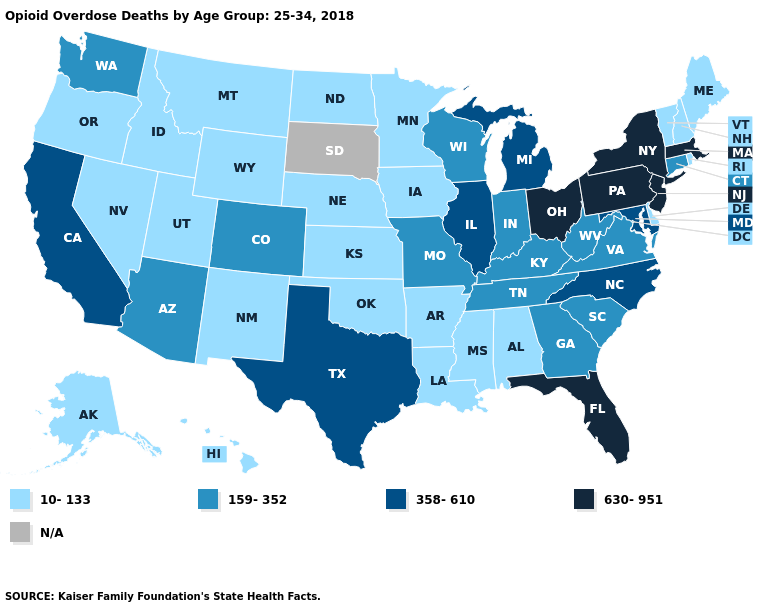Does Iowa have the lowest value in the USA?
Write a very short answer. Yes. Does the map have missing data?
Quick response, please. Yes. What is the highest value in the USA?
Give a very brief answer. 630-951. Among the states that border Illinois , does Missouri have the highest value?
Give a very brief answer. Yes. How many symbols are there in the legend?
Answer briefly. 5. Does West Virginia have the lowest value in the USA?
Be succinct. No. Name the states that have a value in the range 159-352?
Short answer required. Arizona, Colorado, Connecticut, Georgia, Indiana, Kentucky, Missouri, South Carolina, Tennessee, Virginia, Washington, West Virginia, Wisconsin. Name the states that have a value in the range N/A?
Answer briefly. South Dakota. Does the map have missing data?
Be succinct. Yes. Does Alabama have the lowest value in the USA?
Give a very brief answer. Yes. What is the value of Minnesota?
Write a very short answer. 10-133. Does the first symbol in the legend represent the smallest category?
Be succinct. Yes. 